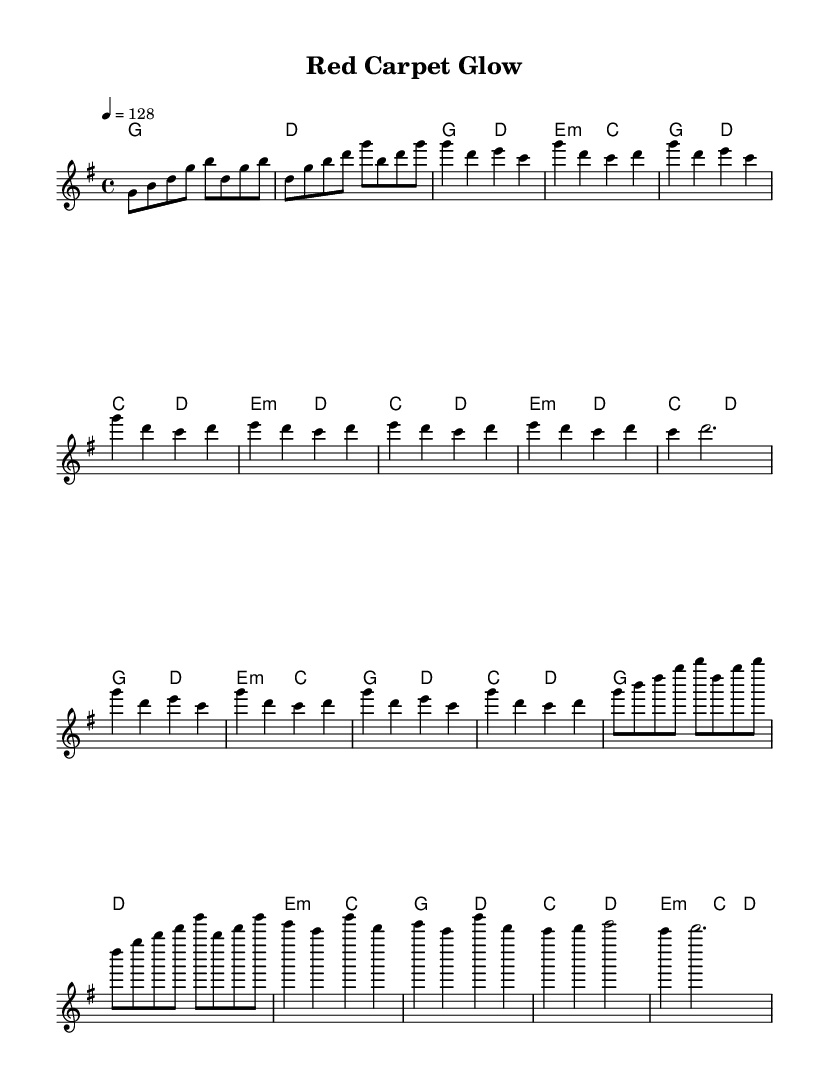What is the key signature of this music? The key signature is G major, which has one sharp (F#). This can be determined by looking at the key signature indicated at the beginning of the score.
Answer: G major What is the time signature of this music? The time signature is 4/4, meaning there are four beats in each measure and the quarter note receives one beat. This is indicated in the top left corner of the sheet music.
Answer: 4/4 What is the tempo marking of this piece? The tempo marking is 128 beats per minute. This is indicated at the beginning of the score with the instruction "4 = 128", showing how fast the beats should be played.
Answer: 128 How many measures are there in the chorus section? The chorus section consists of four measures, as indicated by the notation during that section of the sheet music. You can count the number of measures labeled "Chorus."
Answer: Four What is the primary mood suggested by the tempo and key signature? The tempo of 128 beats per minute in G major usually suggests an upbeat and energetic mood, typical of K-Pop tracks designed for dance. This can be inferred from the fast tempo and lively progressions associated with the genre.
Answer: Energetic What is the harmonic structure of the Verse? The harmonic structure for the Verse consists of G major and D major chords primarily, following a pattern of G to D, and then E minor to C in alternating measures. This repetitive structure contributes to a catchy and engaging verse typical of K-Pop songs.
Answer: G and D What is the function of the Post-Chorus in this piece? The Post-Chorus serves as a transition from the Chorus back to the Verse, often providing a reset in dynamics and rhythm. It consists of measures that repeat the earlier material, reinforcing the catchy themes popular in K-Pop, typical of their song structures.
Answer: Transition 